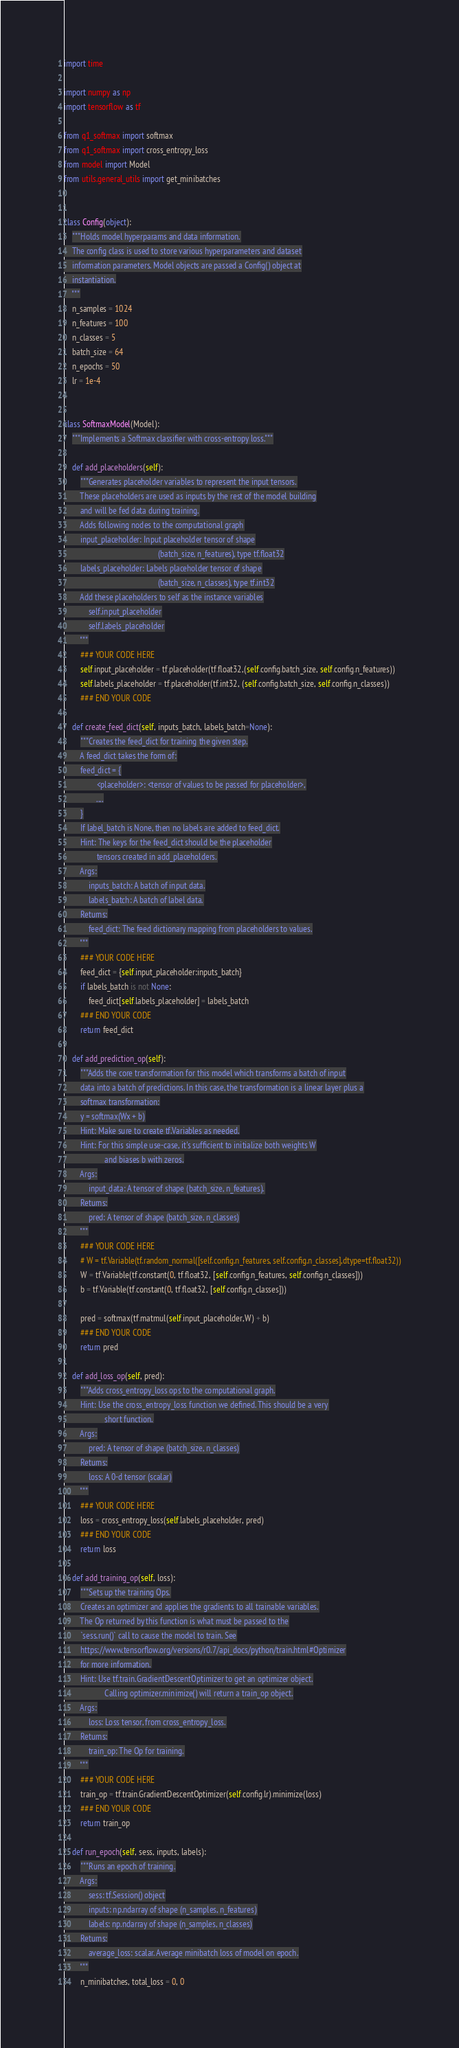<code> <loc_0><loc_0><loc_500><loc_500><_Python_>import time

import numpy as np
import tensorflow as tf

from q1_softmax import softmax
from q1_softmax import cross_entropy_loss
from model import Model
from utils.general_utils import get_minibatches


class Config(object):
    """Holds model hyperparams and data information.
    The config class is used to store various hyperparameters and dataset
    information parameters. Model objects are passed a Config() object at
    instantiation.
    """
    n_samples = 1024
    n_features = 100
    n_classes = 5
    batch_size = 64
    n_epochs = 50
    lr = 1e-4


class SoftmaxModel(Model):
    """Implements a Softmax classifier with cross-entropy loss."""

    def add_placeholders(self):
        """Generates placeholder variables to represent the input tensors.
        These placeholders are used as inputs by the rest of the model building
        and will be fed data during training.
        Adds following nodes to the computational graph
        input_placeholder: Input placeholder tensor of shape
                                              (batch_size, n_features), type tf.float32
        labels_placeholder: Labels placeholder tensor of shape
                                              (batch_size, n_classes), type tf.int32
        Add these placeholders to self as the instance variables
            self.input_placeholder
            self.labels_placeholder
        """
        ### YOUR CODE HERE
        self.input_placeholder = tf.placeholder(tf.float32,(self.config.batch_size, self.config.n_features))
        self.labels_placeholder = tf.placeholder(tf.int32, (self.config.batch_size, self.config.n_classes))
        ### END YOUR CODE

    def create_feed_dict(self, inputs_batch, labels_batch=None):
        """Creates the feed_dict for training the given step.
        A feed_dict takes the form of:
        feed_dict = {
                <placeholder>: <tensor of values to be passed for placeholder>,
                ....
        }
        If label_batch is None, then no labels are added to feed_dict.
        Hint: The keys for the feed_dict should be the placeholder
                tensors created in add_placeholders.
        Args:
            inputs_batch: A batch of input data.
            labels_batch: A batch of label data.
        Returns:
            feed_dict: The feed dictionary mapping from placeholders to values.
        """
        ### YOUR CODE HERE
        feed_dict = {self.input_placeholder:inputs_batch}
        if labels_batch is not None:
            feed_dict[self.labels_placeholder] = labels_batch
        ### END YOUR CODE
        return feed_dict

    def add_prediction_op(self):
        """Adds the core transformation for this model which transforms a batch of input
        data into a batch of predictions. In this case, the transformation is a linear layer plus a
        softmax transformation:
        y = softmax(Wx + b)
        Hint: Make sure to create tf.Variables as needed.
        Hint: For this simple use-case, it's sufficient to initialize both weights W
                    and biases b with zeros.
        Args:
            input_data: A tensor of shape (batch_size, n_features).
        Returns:
            pred: A tensor of shape (batch_size, n_classes)
        """
        ### YOUR CODE HERE
        # W = tf.Variable(tf.random_normal([self.config.n_features, self.config.n_classes],dtype=tf.float32))
        W = tf.Variable(tf.constant(0, tf.float32, [self.config.n_features, self.config.n_classes]))
        b = tf.Variable(tf.constant(0, tf.float32, [self.config.n_classes]))

        pred = softmax(tf.matmul(self.input_placeholder,W) + b)
        ### END YOUR CODE
        return pred

    def add_loss_op(self, pred):
        """Adds cross_entropy_loss ops to the computational graph.
        Hint: Use the cross_entropy_loss function we defined. This should be a very
                    short function.
        Args:
            pred: A tensor of shape (batch_size, n_classes)
        Returns:
            loss: A 0-d tensor (scalar)
        """
        ### YOUR CODE HERE
        loss = cross_entropy_loss(self.labels_placeholder, pred)
        ### END YOUR CODE
        return loss

    def add_training_op(self, loss):
        """Sets up the training Ops.
        Creates an optimizer and applies the gradients to all trainable variables.
        The Op returned by this function is what must be passed to the
        `sess.run()` call to cause the model to train. See
        https://www.tensorflow.org/versions/r0.7/api_docs/python/train.html#Optimizer
        for more information.
        Hint: Use tf.train.GradientDescentOptimizer to get an optimizer object.
                    Calling optimizer.minimize() will return a train_op object.
        Args:
            loss: Loss tensor, from cross_entropy_loss.
        Returns:
            train_op: The Op for training.
        """
        ### YOUR CODE HERE
        train_op = tf.train.GradientDescentOptimizer(self.config.lr).minimize(loss)
        ### END YOUR CODE
        return train_op

    def run_epoch(self, sess, inputs, labels):
        """Runs an epoch of training.
        Args:
            sess: tf.Session() object
            inputs: np.ndarray of shape (n_samples, n_features)
            labels: np.ndarray of shape (n_samples, n_classes)
        Returns:
            average_loss: scalar. Average minibatch loss of model on epoch.
        """
        n_minibatches, total_loss = 0, 0</code> 